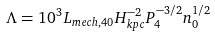<formula> <loc_0><loc_0><loc_500><loc_500>\Lambda = 1 0 ^ { 3 } L _ { m e c h , 4 0 } H _ { k p c } ^ { - 2 } P _ { 4 } ^ { - 3 / 2 } n _ { 0 } ^ { 1 / 2 }</formula> 